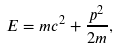Convert formula to latex. <formula><loc_0><loc_0><loc_500><loc_500>E = m c ^ { 2 } + { \frac { p ^ { 2 } } { 2 m } } ,</formula> 